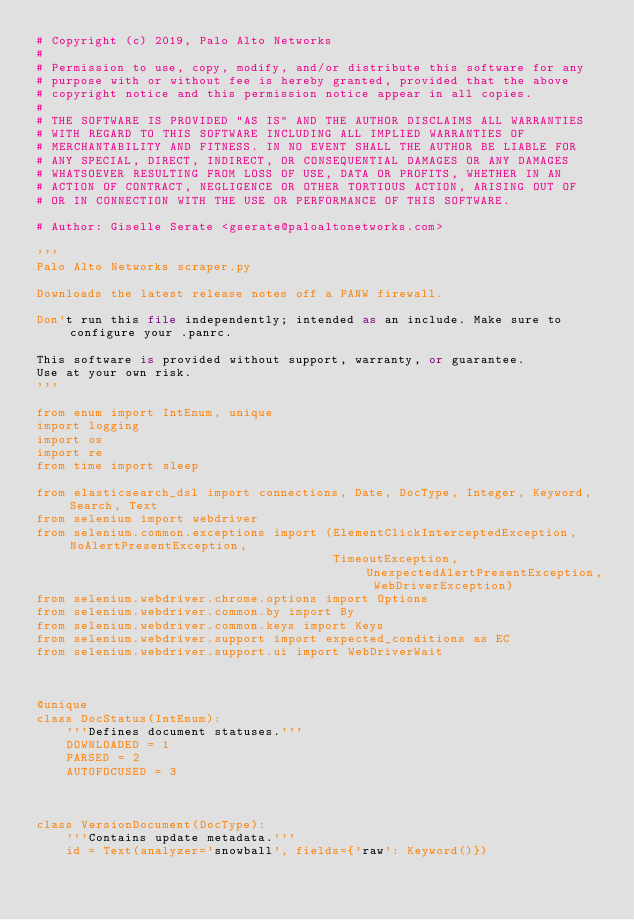<code> <loc_0><loc_0><loc_500><loc_500><_Python_># Copyright (c) 2019, Palo Alto Networks
#
# Permission to use, copy, modify, and/or distribute this software for any
# purpose with or without fee is hereby granted, provided that the above
# copyright notice and this permission notice appear in all copies.
#
# THE SOFTWARE IS PROVIDED "AS IS" AND THE AUTHOR DISCLAIMS ALL WARRANTIES
# WITH REGARD TO THIS SOFTWARE INCLUDING ALL IMPLIED WARRANTIES OF
# MERCHANTABILITY AND FITNESS. IN NO EVENT SHALL THE AUTHOR BE LIABLE FOR
# ANY SPECIAL, DIRECT, INDIRECT, OR CONSEQUENTIAL DAMAGES OR ANY DAMAGES
# WHATSOEVER RESULTING FROM LOSS OF USE, DATA OR PROFITS, WHETHER IN AN
# ACTION OF CONTRACT, NEGLIGENCE OR OTHER TORTIOUS ACTION, ARISING OUT OF
# OR IN CONNECTION WITH THE USE OR PERFORMANCE OF THIS SOFTWARE.

# Author: Giselle Serate <gserate@paloaltonetworks.com>

'''
Palo Alto Networks scraper.py

Downloads the latest release notes off a PANW firewall.

Don't run this file independently; intended as an include. Make sure to configure your .panrc.

This software is provided without support, warranty, or guarantee.
Use at your own risk.
'''

from enum import IntEnum, unique
import logging
import os
import re
from time import sleep

from elasticsearch_dsl import connections, Date, DocType, Integer, Keyword, Search, Text
from selenium import webdriver
from selenium.common.exceptions import (ElementClickInterceptedException, NoAlertPresentException,
                                        TimeoutException, UnexpectedAlertPresentException, WebDriverException)
from selenium.webdriver.chrome.options import Options
from selenium.webdriver.common.by import By
from selenium.webdriver.common.keys import Keys
from selenium.webdriver.support import expected_conditions as EC
from selenium.webdriver.support.ui import WebDriverWait



@unique
class DocStatus(IntEnum):
    '''Defines document statuses.'''
    DOWNLOADED = 1
    PARSED = 2
    AUTOFOCUSED = 3



class VersionDocument(DocType):
    '''Contains update metadata.'''
    id = Text(analyzer='snowball', fields={'raw': Keyword()})</code> 